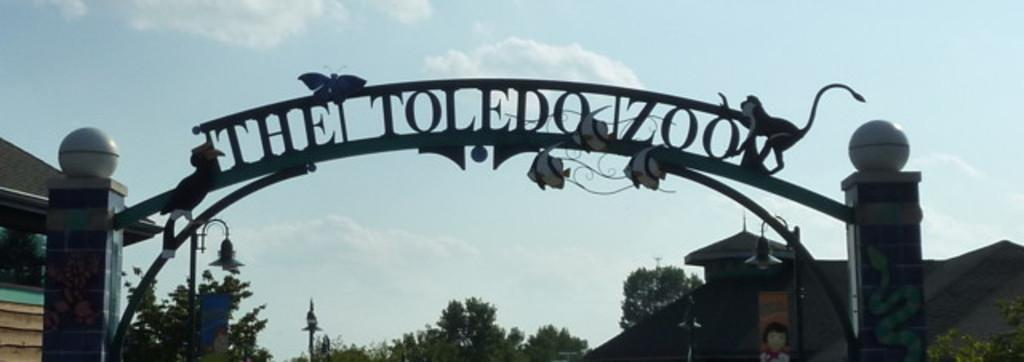What is the main subject in the foreground of the image? There is an arc of a zoo in the foreground of the image. What can be seen in the background of the image? There are trees and buildings in the background of the image. Are there any visible light sources in the image? Yes, there are lights visible in the image. What type of structures are present on the arc? There are structures of animals on the arc. Where is the pin located in the image? There is no pin present in the image. What type of box can be seen on the arc? There is no box present on the arc in the image. 